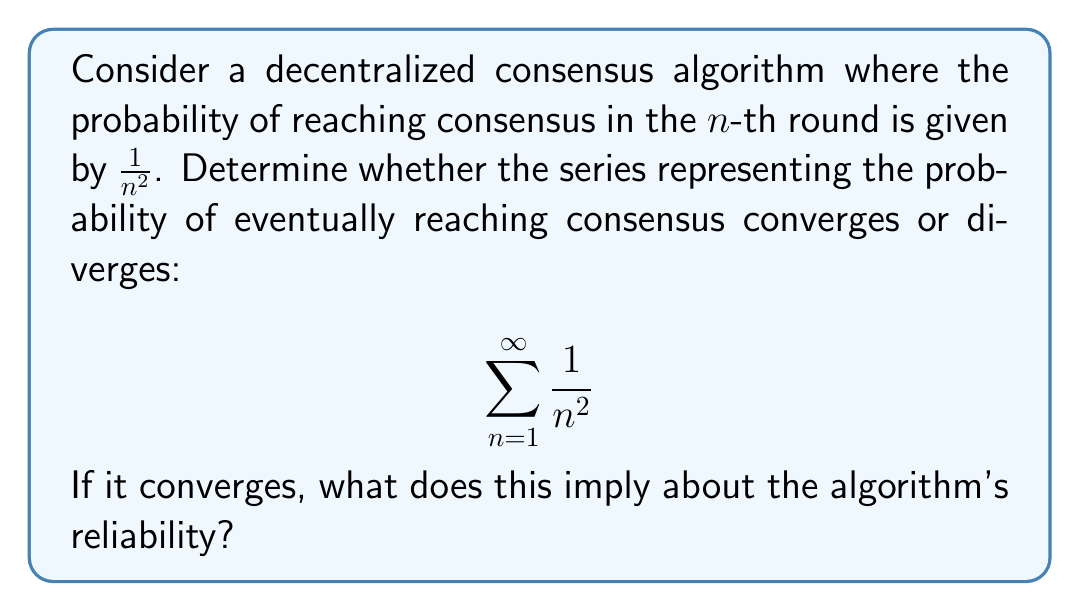Show me your answer to this math problem. To determine the convergence of this series, we can use the p-series test:

1) The general form of a p-series is $\sum_{n=1}^{\infty} \frac{1}{n^p}$

2) In this case, $p = 2$

3) The p-series convergence theorem states:
   - If $p > 1$, the series converges
   - If $p \leq 1$, the series diverges

4) Since $p = 2 > 1$, this series converges

5) The exact sum of this series is known:

   $$\sum_{n=1}^{\infty} \frac{1}{n^2} = \frac{\pi^2}{6}$$

6) This sum is approximately equal to 1.6449...

Interpretation for the consensus algorithm:
The convergence of this series implies that the probability of eventually reaching consensus is 1 (certainty). This is because:

- The sum represents the total probability of reaching consensus across all rounds
- The sum converges to a value less than 1 ($\frac{\pi^2}{6} \approx 1.6449...$)
- In probability theory, if a series of probabilities for mutually exclusive events converges to a value greater than 1, we interpret this as certainty (probability 1)

Therefore, the algorithm is guaranteed to reach consensus eventually, making it reliable in the long run. However, the rate of convergence (how quickly it reaches consensus) may still be slow due to the decreasing probabilities in later rounds.
Answer: The series $\sum_{n=1}^{\infty} \frac{1}{n^2}$ converges to $\frac{\pi^2}{6}$. This implies that the decentralized consensus algorithm is reliable and will eventually reach consensus with probability 1. 